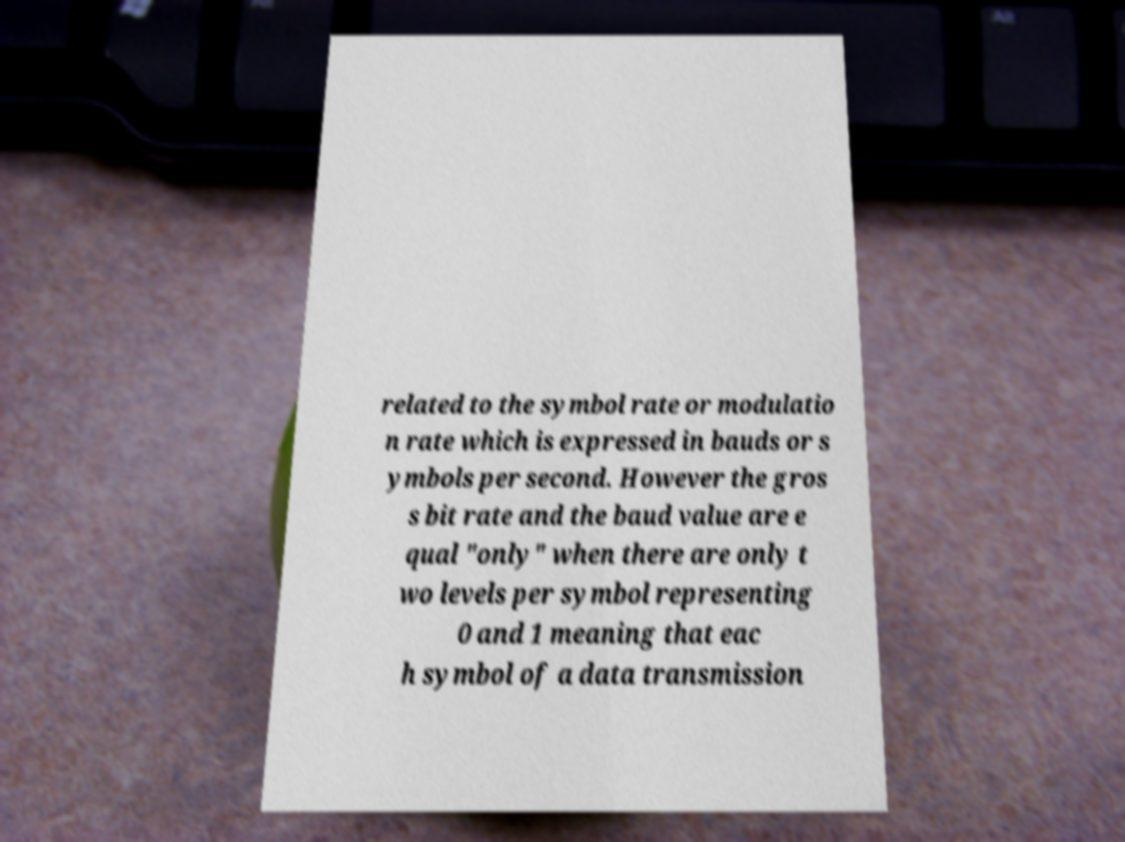Could you assist in decoding the text presented in this image and type it out clearly? related to the symbol rate or modulatio n rate which is expressed in bauds or s ymbols per second. However the gros s bit rate and the baud value are e qual "only" when there are only t wo levels per symbol representing 0 and 1 meaning that eac h symbol of a data transmission 